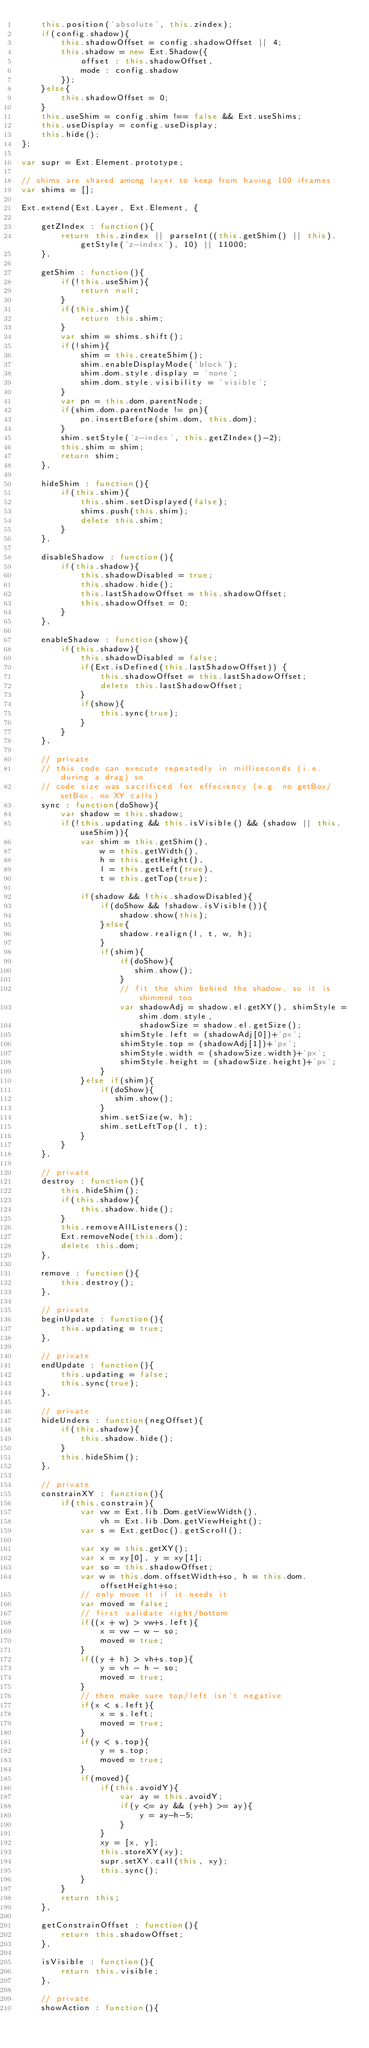Convert code to text. <code><loc_0><loc_0><loc_500><loc_500><_JavaScript_>    this.position('absolute', this.zindex);
    if(config.shadow){
        this.shadowOffset = config.shadowOffset || 4;
        this.shadow = new Ext.Shadow({
            offset : this.shadowOffset,
            mode : config.shadow
        });
    }else{
        this.shadowOffset = 0;
    }
    this.useShim = config.shim !== false && Ext.useShims;
    this.useDisplay = config.useDisplay;
    this.hide();
};

var supr = Ext.Element.prototype;

// shims are shared among layer to keep from having 100 iframes
var shims = [];

Ext.extend(Ext.Layer, Ext.Element, {

    getZIndex : function(){
        return this.zindex || parseInt((this.getShim() || this).getStyle('z-index'), 10) || 11000;
    },

    getShim : function(){
        if(!this.useShim){
            return null;
        }
        if(this.shim){
            return this.shim;
        }
        var shim = shims.shift();
        if(!shim){
            shim = this.createShim();
            shim.enableDisplayMode('block');
            shim.dom.style.display = 'none';
            shim.dom.style.visibility = 'visible';
        }
        var pn = this.dom.parentNode;
        if(shim.dom.parentNode != pn){
            pn.insertBefore(shim.dom, this.dom);
        }
        shim.setStyle('z-index', this.getZIndex()-2);
        this.shim = shim;
        return shim;
    },

    hideShim : function(){
        if(this.shim){
            this.shim.setDisplayed(false);
            shims.push(this.shim);
            delete this.shim;
        }
    },

    disableShadow : function(){
        if(this.shadow){
            this.shadowDisabled = true;
            this.shadow.hide();
            this.lastShadowOffset = this.shadowOffset;
            this.shadowOffset = 0;
        }
    },

    enableShadow : function(show){
        if(this.shadow){
            this.shadowDisabled = false;
            if(Ext.isDefined(this.lastShadowOffset)) {
                this.shadowOffset = this.lastShadowOffset;
                delete this.lastShadowOffset;
            }
            if(show){
                this.sync(true);
            }
        }
    },

    // private
    // this code can execute repeatedly in milliseconds (i.e. during a drag) so
    // code size was sacrificed for effeciency (e.g. no getBox/setBox, no XY calls)
    sync : function(doShow){
        var shadow = this.shadow;
        if(!this.updating && this.isVisible() && (shadow || this.useShim)){
            var shim = this.getShim(),
                w = this.getWidth(),
                h = this.getHeight(),
                l = this.getLeft(true),
                t = this.getTop(true);

            if(shadow && !this.shadowDisabled){
                if(doShow && !shadow.isVisible()){
                    shadow.show(this);
                }else{
                    shadow.realign(l, t, w, h);
                }
                if(shim){
                    if(doShow){
                       shim.show();
                    }
                    // fit the shim behind the shadow, so it is shimmed too
                    var shadowAdj = shadow.el.getXY(), shimStyle = shim.dom.style,
                        shadowSize = shadow.el.getSize();
                    shimStyle.left = (shadowAdj[0])+'px';
                    shimStyle.top = (shadowAdj[1])+'px';
                    shimStyle.width = (shadowSize.width)+'px';
                    shimStyle.height = (shadowSize.height)+'px';
                }
            }else if(shim){
                if(doShow){
                   shim.show();
                }
                shim.setSize(w, h);
                shim.setLeftTop(l, t);
            }
        }
    },

    // private
    destroy : function(){
        this.hideShim();
        if(this.shadow){
            this.shadow.hide();
        }
        this.removeAllListeners();
        Ext.removeNode(this.dom);
        delete this.dom;
    },

    remove : function(){
        this.destroy();
    },

    // private
    beginUpdate : function(){
        this.updating = true;
    },

    // private
    endUpdate : function(){
        this.updating = false;
        this.sync(true);
    },

    // private
    hideUnders : function(negOffset){
        if(this.shadow){
            this.shadow.hide();
        }
        this.hideShim();
    },

    // private
    constrainXY : function(){
        if(this.constrain){
            var vw = Ext.lib.Dom.getViewWidth(),
                vh = Ext.lib.Dom.getViewHeight();
            var s = Ext.getDoc().getScroll();

            var xy = this.getXY();
            var x = xy[0], y = xy[1];
            var so = this.shadowOffset;
            var w = this.dom.offsetWidth+so, h = this.dom.offsetHeight+so;
            // only move it if it needs it
            var moved = false;
            // first validate right/bottom
            if((x + w) > vw+s.left){
                x = vw - w - so;
                moved = true;
            }
            if((y + h) > vh+s.top){
                y = vh - h - so;
                moved = true;
            }
            // then make sure top/left isn't negative
            if(x < s.left){
                x = s.left;
                moved = true;
            }
            if(y < s.top){
                y = s.top;
                moved = true;
            }
            if(moved){
                if(this.avoidY){
                    var ay = this.avoidY;
                    if(y <= ay && (y+h) >= ay){
                        y = ay-h-5;
                    }
                }
                xy = [x, y];
                this.storeXY(xy);
                supr.setXY.call(this, xy);
                this.sync();
            }
        }
        return this;
    },
    
    getConstrainOffset : function(){
        return this.shadowOffset;    
    },

    isVisible : function(){
        return this.visible;
    },

    // private
    showAction : function(){</code> 